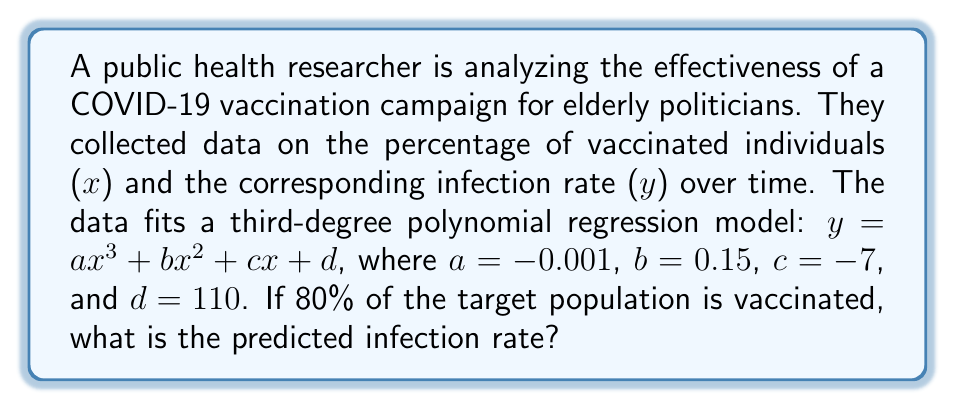Solve this math problem. To solve this problem, we need to follow these steps:

1) We have the polynomial regression model:
   $y = ax^3 + bx^2 + cx + d$

2) We're given the values of the coefficients:
   $a = -0.001$
   $b = 0.15$
   $c = -7$
   $d = 110$

3) We need to find y when x = 80 (80% vaccinated). Let's substitute these values into the equation:

   $y = (-0.001)(80)^3 + (0.15)(80)^2 + (-7)(80) + 110$

4) Now, let's calculate each term:
   $(-0.001)(80)^3 = (-0.001)(512000) = -512$
   $(0.15)(80)^2 = (0.15)(6400) = 960$
   $(-7)(80) = -560$
   $110$ remains as is

5) Sum up all the terms:
   $y = -512 + 960 - 560 + 110$

6) Simplify:
   $y = -2$

Therefore, when 80% of the target population is vaccinated, the predicted infection rate is -2%.

Note: Since infection rates cannot be negative in reality, this result suggests that the model predicts essentially zero infections at this vaccination level, but has some limitations in its accuracy at extreme values.
Answer: -2% 